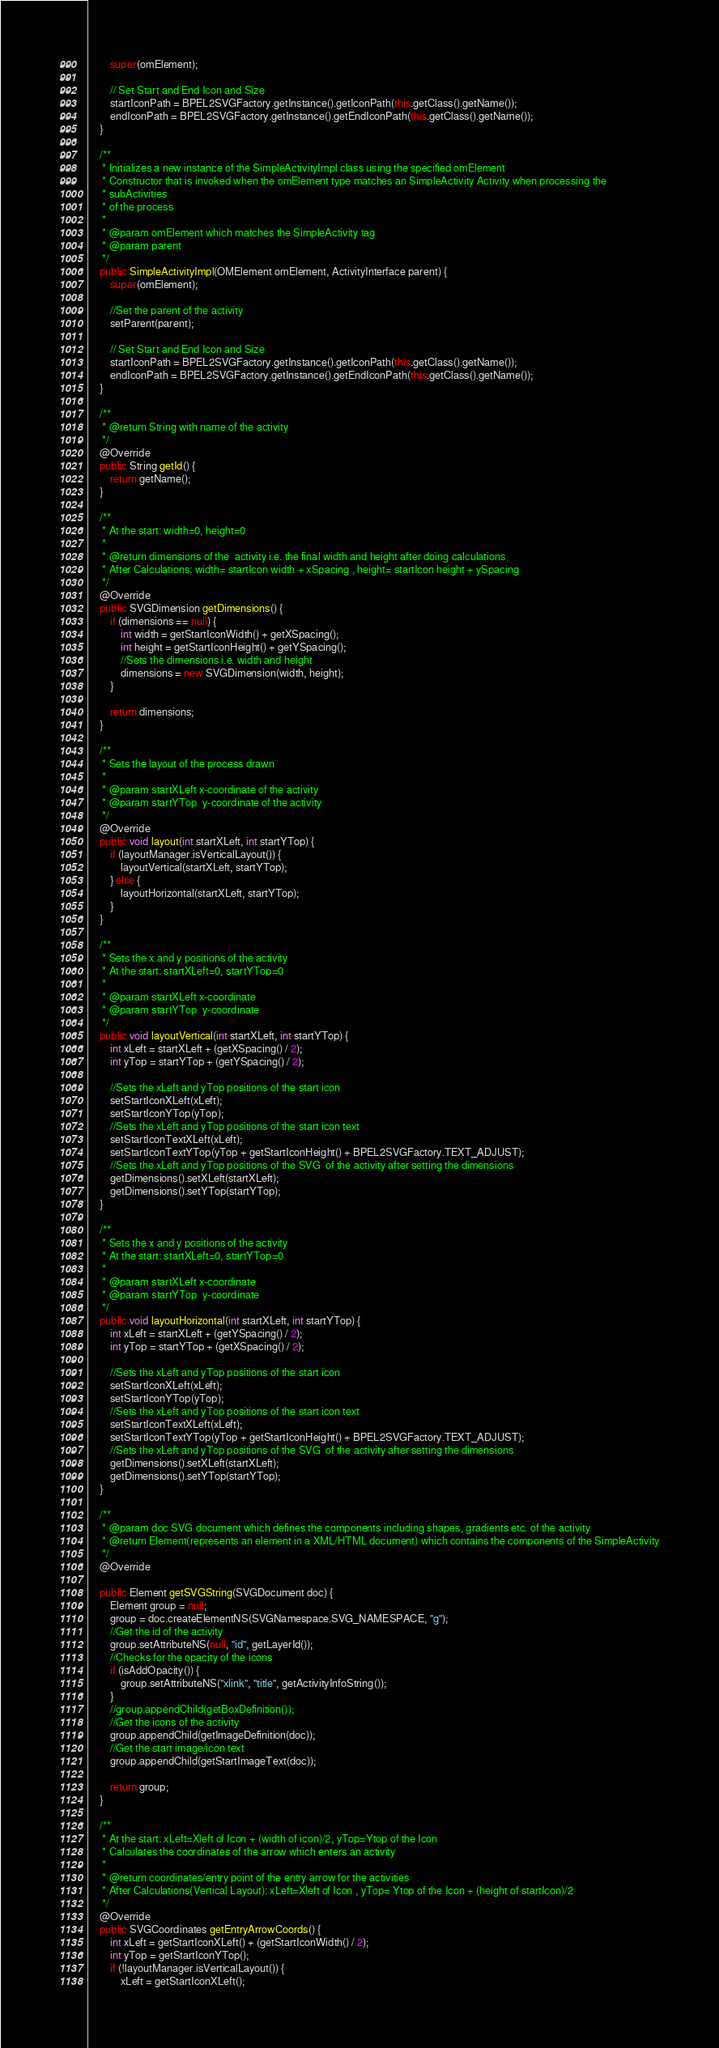Convert code to text. <code><loc_0><loc_0><loc_500><loc_500><_Java_>        super(omElement);

        // Set Start and End Icon and Size
        startIconPath = BPEL2SVGFactory.getInstance().getIconPath(this.getClass().getName());
        endIconPath = BPEL2SVGFactory.getInstance().getEndIconPath(this.getClass().getName());
    }

    /**
     * Initializes a new instance of the SimpleActivityImpl class using the specified omElement
     * Constructor that is invoked when the omElement type matches an SimpleActivity Activity when processing the
     * subActivities
     * of the process
     *
     * @param omElement which matches the SimpleActivity tag
     * @param parent
     */
    public SimpleActivityImpl(OMElement omElement, ActivityInterface parent) {
        super(omElement);

        //Set the parent of the activity
        setParent(parent);

        // Set Start and End Icon and Size
        startIconPath = BPEL2SVGFactory.getInstance().getIconPath(this.getClass().getName());
        endIconPath = BPEL2SVGFactory.getInstance().getEndIconPath(this.getClass().getName());
    }

    /**
     * @return String with name of the activity
     */
    @Override
    public String getId() {
        return getName();
    }

    /**
     * At the start: width=0, height=0
     *
     * @return dimensions of the  activity i.e. the final width and height after doing calculations
     * After Calculations: width= startIcon width + xSpacing , height= startIcon height + ySpacing
     */
    @Override
    public SVGDimension getDimensions() {
        if (dimensions == null) {
            int width = getStartIconWidth() + getXSpacing();
            int height = getStartIconHeight() + getYSpacing();
            //Sets the dimensions i.e. width and height
            dimensions = new SVGDimension(width, height);
        }

        return dimensions;
    }

    /**
     * Sets the layout of the process drawn
     *
     * @param startXLeft x-coordinate of the activity
     * @param startYTop  y-coordinate of the activity
     */
    @Override
    public void layout(int startXLeft, int startYTop) {
        if (layoutManager.isVerticalLayout()) {
            layoutVertical(startXLeft, startYTop);
        } else {
            layoutHorizontal(startXLeft, startYTop);
        }
    }

    /**
     * Sets the x and y positions of the activity
     * At the start: startXLeft=0, startYTop=0
     *
     * @param startXLeft x-coordinate
     * @param startYTop  y-coordinate
     */
    public void layoutVertical(int startXLeft, int startYTop) {
        int xLeft = startXLeft + (getXSpacing() / 2);
        int yTop = startYTop + (getYSpacing() / 2);

        //Sets the xLeft and yTop positions of the start icon
        setStartIconXLeft(xLeft);
        setStartIconYTop(yTop);
        //Sets the xLeft and yTop positions of the start icon text
        setStartIconTextXLeft(xLeft);
        setStartIconTextYTop(yTop + getStartIconHeight() + BPEL2SVGFactory.TEXT_ADJUST);
        //Sets the xLeft and yTop positions of the SVG  of the activity after setting the dimensions
        getDimensions().setXLeft(startXLeft);
        getDimensions().setYTop(startYTop);
    }

    /**
     * Sets the x and y positions of the activity
     * At the start: startXLeft=0, startYTop=0
     *
     * @param startXLeft x-coordinate
     * @param startYTop  y-coordinate
     */
    public void layoutHorizontal(int startXLeft, int startYTop) {
        int xLeft = startXLeft + (getYSpacing() / 2);
        int yTop = startYTop + (getXSpacing() / 2);

        //Sets the xLeft and yTop positions of the start icon
        setStartIconXLeft(xLeft);
        setStartIconYTop(yTop);
        //Sets the xLeft and yTop positions of the start icon text
        setStartIconTextXLeft(xLeft);
        setStartIconTextYTop(yTop + getStartIconHeight() + BPEL2SVGFactory.TEXT_ADJUST);
        //Sets the xLeft and yTop positions of the SVG  of the activity after setting the dimensions
        getDimensions().setXLeft(startXLeft);
        getDimensions().setYTop(startYTop);
    }

    /**
     * @param doc SVG document which defines the components including shapes, gradients etc. of the activity
     * @return Element(represents an element in a XML/HTML document) which contains the components of the SimpleActivity
     */
    @Override

    public Element getSVGString(SVGDocument doc) {
        Element group = null;
        group = doc.createElementNS(SVGNamespace.SVG_NAMESPACE, "g");
        //Get the id of the activity
        group.setAttributeNS(null, "id", getLayerId());
        //Checks for the opacity of the icons
        if (isAddOpacity()) {
            group.setAttributeNS("xlink", "title", getActivityInfoString());
        }
        //group.appendChild(getBoxDefinition());
        //Get the icons of the activity
        group.appendChild(getImageDefinition(doc));
        //Get the start image/icon text
        group.appendChild(getStartImageText(doc));

        return group;
    }

    /**
     * At the start: xLeft=Xleft of Icon + (width of icon)/2, yTop=Ytop of the Icon
     * Calculates the coordinates of the arrow which enters an activity
     *
     * @return coordinates/entry point of the entry arrow for the activities
     * After Calculations(Vertical Layout): xLeft=Xleft of Icon , yTop= Ytop of the Icon + (height of startIcon)/2
     */
    @Override
    public SVGCoordinates getEntryArrowCoords() {
        int xLeft = getStartIconXLeft() + (getStartIconWidth() / 2);
        int yTop = getStartIconYTop();
        if (!layoutManager.isVerticalLayout()) {
            xLeft = getStartIconXLeft();</code> 